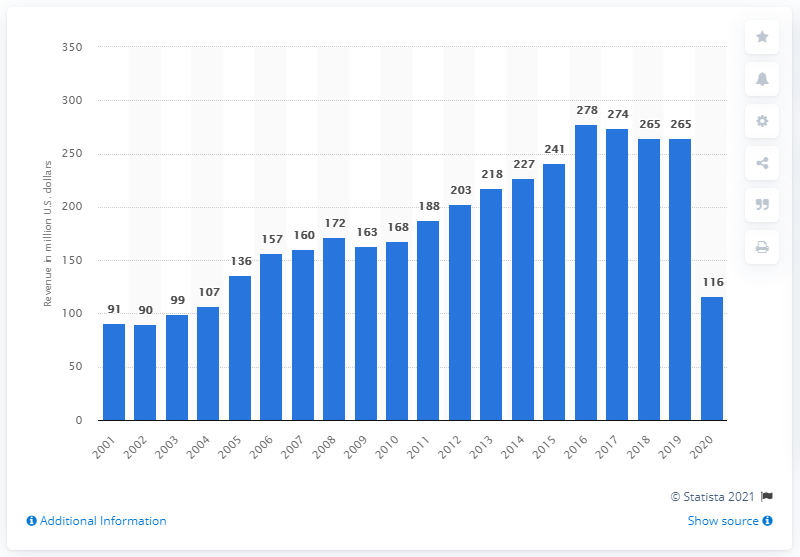Highlight a few significant elements in this photo. In 2000, Rogers Communications paid $136 million for the Toronto Blue Jays. 